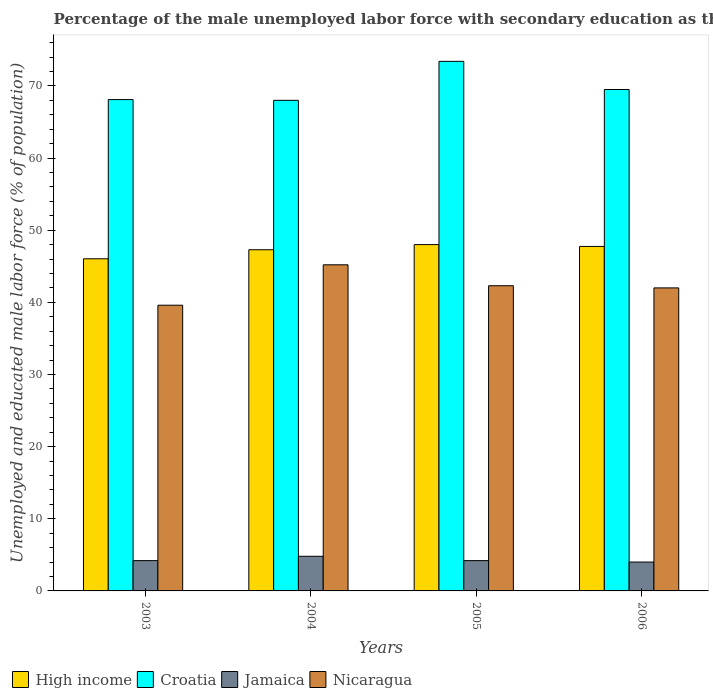How many different coloured bars are there?
Provide a succinct answer. 4. How many bars are there on the 3rd tick from the left?
Keep it short and to the point. 4. How many bars are there on the 3rd tick from the right?
Offer a very short reply. 4. What is the label of the 3rd group of bars from the left?
Give a very brief answer. 2005. In how many cases, is the number of bars for a given year not equal to the number of legend labels?
Your answer should be very brief. 0. What is the percentage of the unemployed male labor force with secondary education in Nicaragua in 2005?
Ensure brevity in your answer.  42.3. Across all years, what is the maximum percentage of the unemployed male labor force with secondary education in Jamaica?
Your answer should be compact. 4.8. Across all years, what is the minimum percentage of the unemployed male labor force with secondary education in Croatia?
Give a very brief answer. 68. In which year was the percentage of the unemployed male labor force with secondary education in Jamaica minimum?
Offer a very short reply. 2006. What is the total percentage of the unemployed male labor force with secondary education in Nicaragua in the graph?
Make the answer very short. 169.1. What is the difference between the percentage of the unemployed male labor force with secondary education in Nicaragua in 2005 and that in 2006?
Provide a short and direct response. 0.3. What is the difference between the percentage of the unemployed male labor force with secondary education in Croatia in 2005 and the percentage of the unemployed male labor force with secondary education in Jamaica in 2003?
Make the answer very short. 69.2. What is the average percentage of the unemployed male labor force with secondary education in High income per year?
Give a very brief answer. 47.27. In the year 2003, what is the difference between the percentage of the unemployed male labor force with secondary education in High income and percentage of the unemployed male labor force with secondary education in Croatia?
Provide a short and direct response. -22.06. What is the ratio of the percentage of the unemployed male labor force with secondary education in Nicaragua in 2003 to that in 2006?
Give a very brief answer. 0.94. Is the percentage of the unemployed male labor force with secondary education in Croatia in 2004 less than that in 2006?
Provide a succinct answer. Yes. What is the difference between the highest and the second highest percentage of the unemployed male labor force with secondary education in Jamaica?
Your response must be concise. 0.6. What is the difference between the highest and the lowest percentage of the unemployed male labor force with secondary education in Nicaragua?
Ensure brevity in your answer.  5.6. Is the sum of the percentage of the unemployed male labor force with secondary education in Nicaragua in 2004 and 2006 greater than the maximum percentage of the unemployed male labor force with secondary education in Jamaica across all years?
Make the answer very short. Yes. Is it the case that in every year, the sum of the percentage of the unemployed male labor force with secondary education in Jamaica and percentage of the unemployed male labor force with secondary education in Nicaragua is greater than the sum of percentage of the unemployed male labor force with secondary education in Croatia and percentage of the unemployed male labor force with secondary education in High income?
Keep it short and to the point. No. What does the 4th bar from the left in 2004 represents?
Offer a terse response. Nicaragua. What does the 3rd bar from the right in 2004 represents?
Keep it short and to the point. Croatia. Are all the bars in the graph horizontal?
Give a very brief answer. No. Does the graph contain any zero values?
Ensure brevity in your answer.  No. How are the legend labels stacked?
Your answer should be very brief. Horizontal. What is the title of the graph?
Provide a succinct answer. Percentage of the male unemployed labor force with secondary education as their highest grade. What is the label or title of the Y-axis?
Keep it short and to the point. Unemployed and educated male labor force (% of population). What is the Unemployed and educated male labor force (% of population) of High income in 2003?
Give a very brief answer. 46.04. What is the Unemployed and educated male labor force (% of population) in Croatia in 2003?
Offer a very short reply. 68.1. What is the Unemployed and educated male labor force (% of population) in Jamaica in 2003?
Provide a succinct answer. 4.2. What is the Unemployed and educated male labor force (% of population) in Nicaragua in 2003?
Offer a terse response. 39.6. What is the Unemployed and educated male labor force (% of population) of High income in 2004?
Your answer should be very brief. 47.29. What is the Unemployed and educated male labor force (% of population) in Croatia in 2004?
Your answer should be very brief. 68. What is the Unemployed and educated male labor force (% of population) in Jamaica in 2004?
Provide a short and direct response. 4.8. What is the Unemployed and educated male labor force (% of population) in Nicaragua in 2004?
Provide a succinct answer. 45.2. What is the Unemployed and educated male labor force (% of population) of High income in 2005?
Your answer should be very brief. 48. What is the Unemployed and educated male labor force (% of population) of Croatia in 2005?
Offer a terse response. 73.4. What is the Unemployed and educated male labor force (% of population) in Jamaica in 2005?
Give a very brief answer. 4.2. What is the Unemployed and educated male labor force (% of population) in Nicaragua in 2005?
Ensure brevity in your answer.  42.3. What is the Unemployed and educated male labor force (% of population) of High income in 2006?
Offer a terse response. 47.74. What is the Unemployed and educated male labor force (% of population) in Croatia in 2006?
Provide a short and direct response. 69.5. Across all years, what is the maximum Unemployed and educated male labor force (% of population) of High income?
Provide a succinct answer. 48. Across all years, what is the maximum Unemployed and educated male labor force (% of population) of Croatia?
Make the answer very short. 73.4. Across all years, what is the maximum Unemployed and educated male labor force (% of population) of Jamaica?
Your answer should be compact. 4.8. Across all years, what is the maximum Unemployed and educated male labor force (% of population) in Nicaragua?
Provide a short and direct response. 45.2. Across all years, what is the minimum Unemployed and educated male labor force (% of population) in High income?
Your response must be concise. 46.04. Across all years, what is the minimum Unemployed and educated male labor force (% of population) of Nicaragua?
Ensure brevity in your answer.  39.6. What is the total Unemployed and educated male labor force (% of population) in High income in the graph?
Offer a terse response. 189.07. What is the total Unemployed and educated male labor force (% of population) of Croatia in the graph?
Your response must be concise. 279. What is the total Unemployed and educated male labor force (% of population) in Nicaragua in the graph?
Offer a very short reply. 169.1. What is the difference between the Unemployed and educated male labor force (% of population) in High income in 2003 and that in 2004?
Ensure brevity in your answer.  -1.25. What is the difference between the Unemployed and educated male labor force (% of population) in Croatia in 2003 and that in 2004?
Give a very brief answer. 0.1. What is the difference between the Unemployed and educated male labor force (% of population) in Jamaica in 2003 and that in 2004?
Offer a very short reply. -0.6. What is the difference between the Unemployed and educated male labor force (% of population) in High income in 2003 and that in 2005?
Offer a terse response. -1.97. What is the difference between the Unemployed and educated male labor force (% of population) of Jamaica in 2003 and that in 2005?
Offer a very short reply. 0. What is the difference between the Unemployed and educated male labor force (% of population) in High income in 2003 and that in 2006?
Ensure brevity in your answer.  -1.71. What is the difference between the Unemployed and educated male labor force (% of population) of Nicaragua in 2003 and that in 2006?
Offer a very short reply. -2.4. What is the difference between the Unemployed and educated male labor force (% of population) of High income in 2004 and that in 2005?
Give a very brief answer. -0.71. What is the difference between the Unemployed and educated male labor force (% of population) in Croatia in 2004 and that in 2005?
Offer a very short reply. -5.4. What is the difference between the Unemployed and educated male labor force (% of population) in High income in 2004 and that in 2006?
Offer a very short reply. -0.46. What is the difference between the Unemployed and educated male labor force (% of population) of Croatia in 2004 and that in 2006?
Ensure brevity in your answer.  -1.5. What is the difference between the Unemployed and educated male labor force (% of population) in Jamaica in 2004 and that in 2006?
Keep it short and to the point. 0.8. What is the difference between the Unemployed and educated male labor force (% of population) in High income in 2005 and that in 2006?
Offer a very short reply. 0.26. What is the difference between the Unemployed and educated male labor force (% of population) in Nicaragua in 2005 and that in 2006?
Ensure brevity in your answer.  0.3. What is the difference between the Unemployed and educated male labor force (% of population) of High income in 2003 and the Unemployed and educated male labor force (% of population) of Croatia in 2004?
Give a very brief answer. -21.96. What is the difference between the Unemployed and educated male labor force (% of population) of High income in 2003 and the Unemployed and educated male labor force (% of population) of Jamaica in 2004?
Keep it short and to the point. 41.24. What is the difference between the Unemployed and educated male labor force (% of population) of High income in 2003 and the Unemployed and educated male labor force (% of population) of Nicaragua in 2004?
Ensure brevity in your answer.  0.84. What is the difference between the Unemployed and educated male labor force (% of population) of Croatia in 2003 and the Unemployed and educated male labor force (% of population) of Jamaica in 2004?
Your response must be concise. 63.3. What is the difference between the Unemployed and educated male labor force (% of population) of Croatia in 2003 and the Unemployed and educated male labor force (% of population) of Nicaragua in 2004?
Provide a succinct answer. 22.9. What is the difference between the Unemployed and educated male labor force (% of population) in Jamaica in 2003 and the Unemployed and educated male labor force (% of population) in Nicaragua in 2004?
Ensure brevity in your answer.  -41. What is the difference between the Unemployed and educated male labor force (% of population) in High income in 2003 and the Unemployed and educated male labor force (% of population) in Croatia in 2005?
Offer a terse response. -27.36. What is the difference between the Unemployed and educated male labor force (% of population) in High income in 2003 and the Unemployed and educated male labor force (% of population) in Jamaica in 2005?
Give a very brief answer. 41.84. What is the difference between the Unemployed and educated male labor force (% of population) in High income in 2003 and the Unemployed and educated male labor force (% of population) in Nicaragua in 2005?
Ensure brevity in your answer.  3.74. What is the difference between the Unemployed and educated male labor force (% of population) in Croatia in 2003 and the Unemployed and educated male labor force (% of population) in Jamaica in 2005?
Offer a very short reply. 63.9. What is the difference between the Unemployed and educated male labor force (% of population) in Croatia in 2003 and the Unemployed and educated male labor force (% of population) in Nicaragua in 2005?
Your response must be concise. 25.8. What is the difference between the Unemployed and educated male labor force (% of population) of Jamaica in 2003 and the Unemployed and educated male labor force (% of population) of Nicaragua in 2005?
Your answer should be compact. -38.1. What is the difference between the Unemployed and educated male labor force (% of population) of High income in 2003 and the Unemployed and educated male labor force (% of population) of Croatia in 2006?
Your answer should be very brief. -23.46. What is the difference between the Unemployed and educated male labor force (% of population) in High income in 2003 and the Unemployed and educated male labor force (% of population) in Jamaica in 2006?
Make the answer very short. 42.04. What is the difference between the Unemployed and educated male labor force (% of population) of High income in 2003 and the Unemployed and educated male labor force (% of population) of Nicaragua in 2006?
Provide a short and direct response. 4.04. What is the difference between the Unemployed and educated male labor force (% of population) in Croatia in 2003 and the Unemployed and educated male labor force (% of population) in Jamaica in 2006?
Your response must be concise. 64.1. What is the difference between the Unemployed and educated male labor force (% of population) of Croatia in 2003 and the Unemployed and educated male labor force (% of population) of Nicaragua in 2006?
Provide a short and direct response. 26.1. What is the difference between the Unemployed and educated male labor force (% of population) of Jamaica in 2003 and the Unemployed and educated male labor force (% of population) of Nicaragua in 2006?
Your answer should be very brief. -37.8. What is the difference between the Unemployed and educated male labor force (% of population) of High income in 2004 and the Unemployed and educated male labor force (% of population) of Croatia in 2005?
Your answer should be compact. -26.11. What is the difference between the Unemployed and educated male labor force (% of population) of High income in 2004 and the Unemployed and educated male labor force (% of population) of Jamaica in 2005?
Keep it short and to the point. 43.09. What is the difference between the Unemployed and educated male labor force (% of population) in High income in 2004 and the Unemployed and educated male labor force (% of population) in Nicaragua in 2005?
Keep it short and to the point. 4.99. What is the difference between the Unemployed and educated male labor force (% of population) in Croatia in 2004 and the Unemployed and educated male labor force (% of population) in Jamaica in 2005?
Your answer should be compact. 63.8. What is the difference between the Unemployed and educated male labor force (% of population) in Croatia in 2004 and the Unemployed and educated male labor force (% of population) in Nicaragua in 2005?
Ensure brevity in your answer.  25.7. What is the difference between the Unemployed and educated male labor force (% of population) of Jamaica in 2004 and the Unemployed and educated male labor force (% of population) of Nicaragua in 2005?
Make the answer very short. -37.5. What is the difference between the Unemployed and educated male labor force (% of population) of High income in 2004 and the Unemployed and educated male labor force (% of population) of Croatia in 2006?
Offer a very short reply. -22.21. What is the difference between the Unemployed and educated male labor force (% of population) in High income in 2004 and the Unemployed and educated male labor force (% of population) in Jamaica in 2006?
Offer a terse response. 43.29. What is the difference between the Unemployed and educated male labor force (% of population) in High income in 2004 and the Unemployed and educated male labor force (% of population) in Nicaragua in 2006?
Ensure brevity in your answer.  5.29. What is the difference between the Unemployed and educated male labor force (% of population) in Croatia in 2004 and the Unemployed and educated male labor force (% of population) in Jamaica in 2006?
Your answer should be compact. 64. What is the difference between the Unemployed and educated male labor force (% of population) in Jamaica in 2004 and the Unemployed and educated male labor force (% of population) in Nicaragua in 2006?
Keep it short and to the point. -37.2. What is the difference between the Unemployed and educated male labor force (% of population) of High income in 2005 and the Unemployed and educated male labor force (% of population) of Croatia in 2006?
Offer a very short reply. -21.5. What is the difference between the Unemployed and educated male labor force (% of population) of High income in 2005 and the Unemployed and educated male labor force (% of population) of Jamaica in 2006?
Ensure brevity in your answer.  44. What is the difference between the Unemployed and educated male labor force (% of population) in High income in 2005 and the Unemployed and educated male labor force (% of population) in Nicaragua in 2006?
Provide a succinct answer. 6. What is the difference between the Unemployed and educated male labor force (% of population) of Croatia in 2005 and the Unemployed and educated male labor force (% of population) of Jamaica in 2006?
Your answer should be very brief. 69.4. What is the difference between the Unemployed and educated male labor force (% of population) of Croatia in 2005 and the Unemployed and educated male labor force (% of population) of Nicaragua in 2006?
Your answer should be very brief. 31.4. What is the difference between the Unemployed and educated male labor force (% of population) of Jamaica in 2005 and the Unemployed and educated male labor force (% of population) of Nicaragua in 2006?
Keep it short and to the point. -37.8. What is the average Unemployed and educated male labor force (% of population) in High income per year?
Make the answer very short. 47.27. What is the average Unemployed and educated male labor force (% of population) of Croatia per year?
Ensure brevity in your answer.  69.75. What is the average Unemployed and educated male labor force (% of population) of Jamaica per year?
Provide a succinct answer. 4.3. What is the average Unemployed and educated male labor force (% of population) in Nicaragua per year?
Provide a short and direct response. 42.27. In the year 2003, what is the difference between the Unemployed and educated male labor force (% of population) of High income and Unemployed and educated male labor force (% of population) of Croatia?
Your answer should be very brief. -22.06. In the year 2003, what is the difference between the Unemployed and educated male labor force (% of population) of High income and Unemployed and educated male labor force (% of population) of Jamaica?
Provide a succinct answer. 41.84. In the year 2003, what is the difference between the Unemployed and educated male labor force (% of population) of High income and Unemployed and educated male labor force (% of population) of Nicaragua?
Your response must be concise. 6.44. In the year 2003, what is the difference between the Unemployed and educated male labor force (% of population) in Croatia and Unemployed and educated male labor force (% of population) in Jamaica?
Keep it short and to the point. 63.9. In the year 2003, what is the difference between the Unemployed and educated male labor force (% of population) of Jamaica and Unemployed and educated male labor force (% of population) of Nicaragua?
Offer a very short reply. -35.4. In the year 2004, what is the difference between the Unemployed and educated male labor force (% of population) of High income and Unemployed and educated male labor force (% of population) of Croatia?
Provide a short and direct response. -20.71. In the year 2004, what is the difference between the Unemployed and educated male labor force (% of population) in High income and Unemployed and educated male labor force (% of population) in Jamaica?
Your response must be concise. 42.49. In the year 2004, what is the difference between the Unemployed and educated male labor force (% of population) in High income and Unemployed and educated male labor force (% of population) in Nicaragua?
Keep it short and to the point. 2.09. In the year 2004, what is the difference between the Unemployed and educated male labor force (% of population) of Croatia and Unemployed and educated male labor force (% of population) of Jamaica?
Provide a short and direct response. 63.2. In the year 2004, what is the difference between the Unemployed and educated male labor force (% of population) of Croatia and Unemployed and educated male labor force (% of population) of Nicaragua?
Provide a succinct answer. 22.8. In the year 2004, what is the difference between the Unemployed and educated male labor force (% of population) of Jamaica and Unemployed and educated male labor force (% of population) of Nicaragua?
Your answer should be compact. -40.4. In the year 2005, what is the difference between the Unemployed and educated male labor force (% of population) in High income and Unemployed and educated male labor force (% of population) in Croatia?
Give a very brief answer. -25.4. In the year 2005, what is the difference between the Unemployed and educated male labor force (% of population) of High income and Unemployed and educated male labor force (% of population) of Jamaica?
Offer a terse response. 43.8. In the year 2005, what is the difference between the Unemployed and educated male labor force (% of population) in High income and Unemployed and educated male labor force (% of population) in Nicaragua?
Make the answer very short. 5.7. In the year 2005, what is the difference between the Unemployed and educated male labor force (% of population) of Croatia and Unemployed and educated male labor force (% of population) of Jamaica?
Provide a short and direct response. 69.2. In the year 2005, what is the difference between the Unemployed and educated male labor force (% of population) in Croatia and Unemployed and educated male labor force (% of population) in Nicaragua?
Offer a terse response. 31.1. In the year 2005, what is the difference between the Unemployed and educated male labor force (% of population) of Jamaica and Unemployed and educated male labor force (% of population) of Nicaragua?
Offer a terse response. -38.1. In the year 2006, what is the difference between the Unemployed and educated male labor force (% of population) of High income and Unemployed and educated male labor force (% of population) of Croatia?
Keep it short and to the point. -21.76. In the year 2006, what is the difference between the Unemployed and educated male labor force (% of population) in High income and Unemployed and educated male labor force (% of population) in Jamaica?
Your answer should be very brief. 43.74. In the year 2006, what is the difference between the Unemployed and educated male labor force (% of population) of High income and Unemployed and educated male labor force (% of population) of Nicaragua?
Give a very brief answer. 5.74. In the year 2006, what is the difference between the Unemployed and educated male labor force (% of population) of Croatia and Unemployed and educated male labor force (% of population) of Jamaica?
Provide a short and direct response. 65.5. In the year 2006, what is the difference between the Unemployed and educated male labor force (% of population) in Jamaica and Unemployed and educated male labor force (% of population) in Nicaragua?
Make the answer very short. -38. What is the ratio of the Unemployed and educated male labor force (% of population) in High income in 2003 to that in 2004?
Your response must be concise. 0.97. What is the ratio of the Unemployed and educated male labor force (% of population) in Nicaragua in 2003 to that in 2004?
Keep it short and to the point. 0.88. What is the ratio of the Unemployed and educated male labor force (% of population) of High income in 2003 to that in 2005?
Offer a terse response. 0.96. What is the ratio of the Unemployed and educated male labor force (% of population) of Croatia in 2003 to that in 2005?
Give a very brief answer. 0.93. What is the ratio of the Unemployed and educated male labor force (% of population) in Nicaragua in 2003 to that in 2005?
Give a very brief answer. 0.94. What is the ratio of the Unemployed and educated male labor force (% of population) of High income in 2003 to that in 2006?
Your response must be concise. 0.96. What is the ratio of the Unemployed and educated male labor force (% of population) of Croatia in 2003 to that in 2006?
Ensure brevity in your answer.  0.98. What is the ratio of the Unemployed and educated male labor force (% of population) in Jamaica in 2003 to that in 2006?
Your answer should be very brief. 1.05. What is the ratio of the Unemployed and educated male labor force (% of population) of Nicaragua in 2003 to that in 2006?
Your response must be concise. 0.94. What is the ratio of the Unemployed and educated male labor force (% of population) of High income in 2004 to that in 2005?
Provide a succinct answer. 0.99. What is the ratio of the Unemployed and educated male labor force (% of population) of Croatia in 2004 to that in 2005?
Your answer should be compact. 0.93. What is the ratio of the Unemployed and educated male labor force (% of population) in Jamaica in 2004 to that in 2005?
Your answer should be compact. 1.14. What is the ratio of the Unemployed and educated male labor force (% of population) in Nicaragua in 2004 to that in 2005?
Provide a short and direct response. 1.07. What is the ratio of the Unemployed and educated male labor force (% of population) in High income in 2004 to that in 2006?
Your answer should be compact. 0.99. What is the ratio of the Unemployed and educated male labor force (% of population) of Croatia in 2004 to that in 2006?
Make the answer very short. 0.98. What is the ratio of the Unemployed and educated male labor force (% of population) in Jamaica in 2004 to that in 2006?
Offer a terse response. 1.2. What is the ratio of the Unemployed and educated male labor force (% of population) in Nicaragua in 2004 to that in 2006?
Provide a short and direct response. 1.08. What is the ratio of the Unemployed and educated male labor force (% of population) of High income in 2005 to that in 2006?
Give a very brief answer. 1.01. What is the ratio of the Unemployed and educated male labor force (% of population) of Croatia in 2005 to that in 2006?
Keep it short and to the point. 1.06. What is the ratio of the Unemployed and educated male labor force (% of population) in Nicaragua in 2005 to that in 2006?
Provide a succinct answer. 1.01. What is the difference between the highest and the second highest Unemployed and educated male labor force (% of population) in High income?
Your answer should be very brief. 0.26. What is the difference between the highest and the second highest Unemployed and educated male labor force (% of population) in Croatia?
Provide a short and direct response. 3.9. What is the difference between the highest and the second highest Unemployed and educated male labor force (% of population) in Jamaica?
Your response must be concise. 0.6. What is the difference between the highest and the second highest Unemployed and educated male labor force (% of population) in Nicaragua?
Provide a short and direct response. 2.9. What is the difference between the highest and the lowest Unemployed and educated male labor force (% of population) in High income?
Ensure brevity in your answer.  1.97. What is the difference between the highest and the lowest Unemployed and educated male labor force (% of population) in Croatia?
Your answer should be very brief. 5.4. 